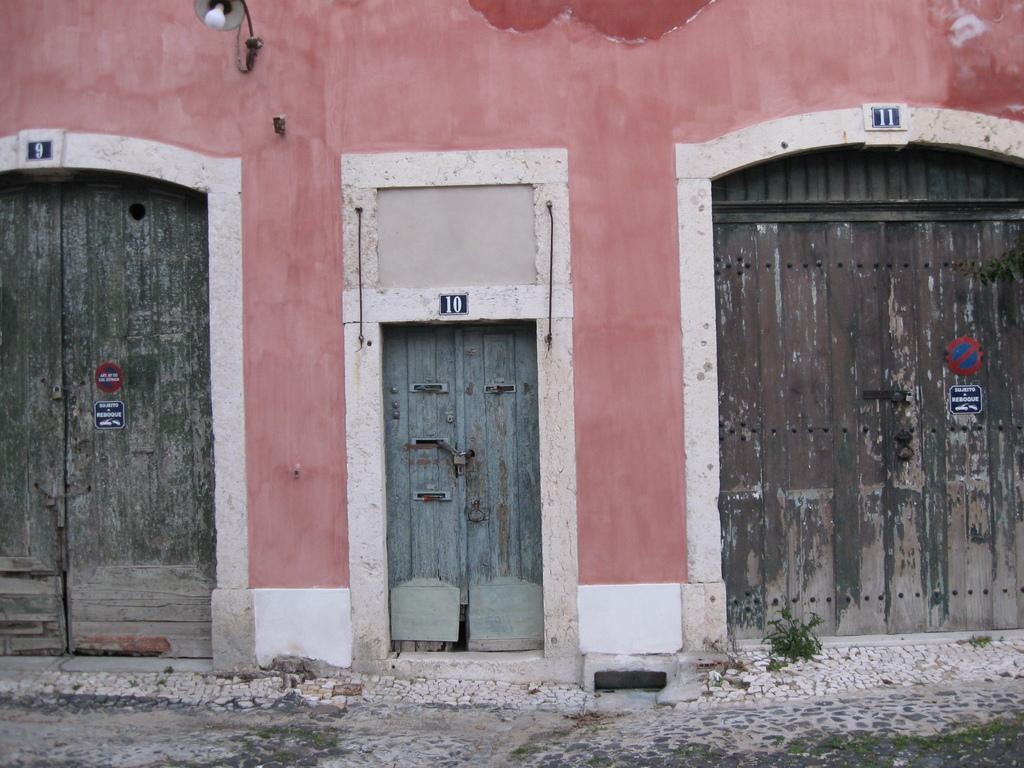What is the main subject of the image? The main subject of the image is a house wall. How many doors are present on the wall? There are three doors on the wall. Can you describe the size of the doors? Two of the doors are big, and one of the doors is small. What other object is attached to the wall? There is a lamp on the wall. What type of teaching is happening in the image? There is no teaching or classroom depicted in the image; it features a house wall with doors and a lamp. Can you tell me how many brains are visible in the image? There are no brains present in the image; it only shows a house wall with doors and a lamp. 